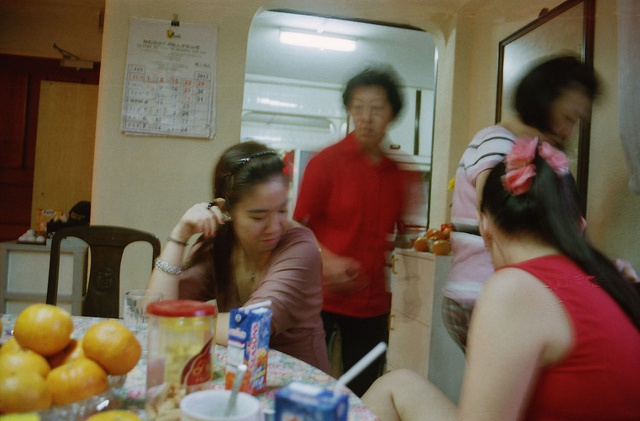Describe the objects in this image and their specific colors. I can see people in black, darkgray, maroon, and brown tones, dining table in black, darkgray, olive, and tan tones, people in black, maroon, and gray tones, people in black, maroon, and gray tones, and people in black, darkgray, and gray tones in this image. 